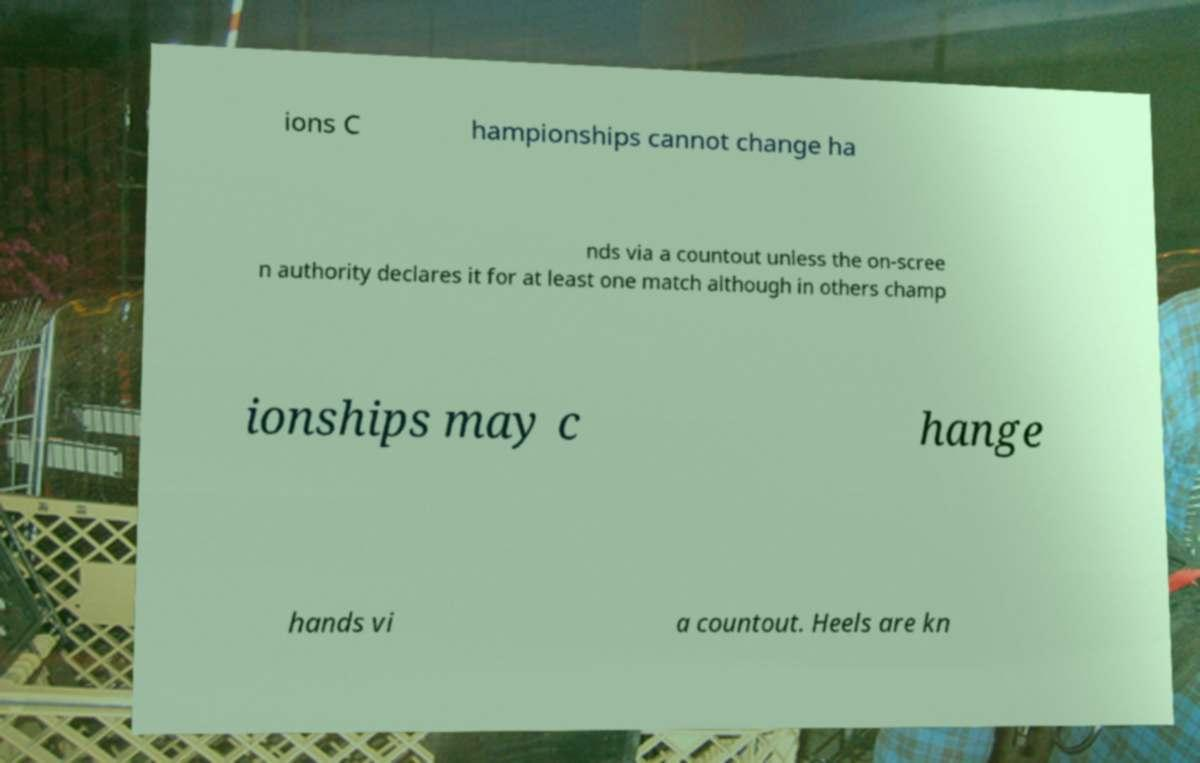Please read and relay the text visible in this image. What does it say? ions C hampionships cannot change ha nds via a countout unless the on-scree n authority declares it for at least one match although in others champ ionships may c hange hands vi a countout. Heels are kn 